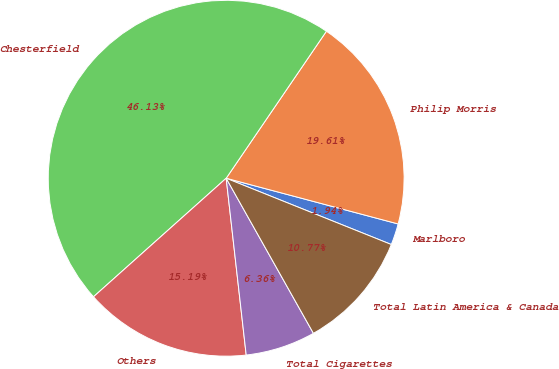Convert chart. <chart><loc_0><loc_0><loc_500><loc_500><pie_chart><fcel>Marlboro<fcel>Philip Morris<fcel>Chesterfield<fcel>Others<fcel>Total Cigarettes<fcel>Total Latin America & Canada<nl><fcel>1.94%<fcel>19.61%<fcel>46.13%<fcel>15.19%<fcel>6.36%<fcel>10.77%<nl></chart> 